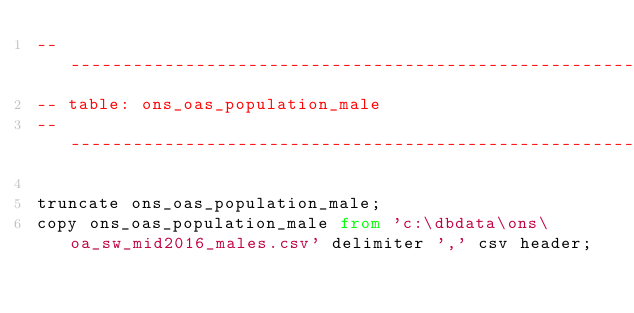<code> <loc_0><loc_0><loc_500><loc_500><_SQL_>---------------------------------------------------------------
-- table: ons_oas_population_male
---------------------------------------------------------------

truncate ons_oas_population_male;
copy ons_oas_population_male from 'c:\dbdata\ons\oa_sw_mid2016_males.csv' delimiter ',' csv header;</code> 